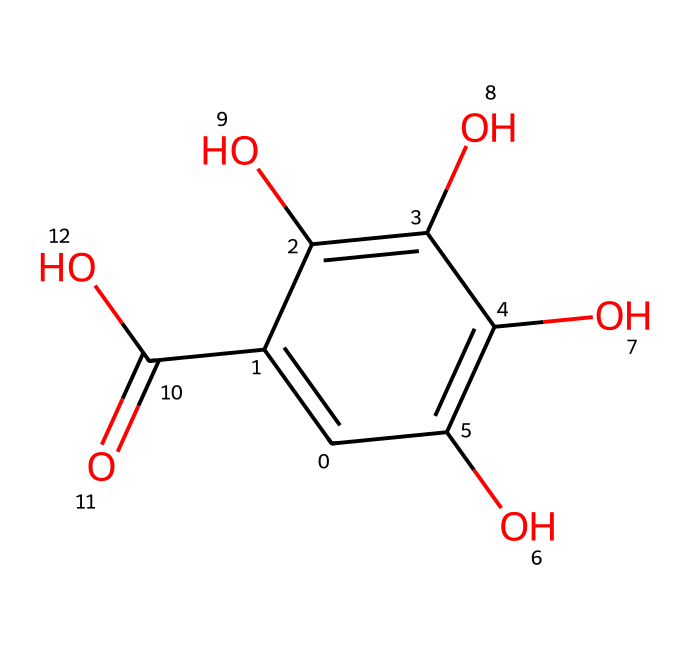What is the main functional group present in this structure? The structure contains multiple -OH groups, which are hydroxyl functional groups. These are indicated by the oxygen atoms bonded to hydrogen in the structure.
Answer: hydroxyl group How many carbon atoms are present in this chemical? Counting the carbon atoms in the SMILES representation, there are six carbon atoms represented by 'C' in the structure.
Answer: six What is the molecular formula of this compound? The structure can be deduced to have a molecular formula of C6H6O6 based on the number of carbon, hydrogen, and oxygen atoms present in it.
Answer: C6H6O6 Is this dye water-soluble? The presence of hydroxyl (-OH) groups in the structure typically suggests that the compound is polar and can form hydrogen bonds with water, indicating high water solubility.
Answer: yes Which type of dye is represented by this structure? The presence of phenolic groups and its use in historical ink suggests that this compound is a type of tannin-based dye, commonly used in inks like iron gall ink.
Answer: tannin-based dye What is the significance of iron gall ink in historical context? Iron gall ink was widely used in manuscripts and documents due to its deep black color and durability, making it significant for preserving historical texts.
Answer: preservation of texts 